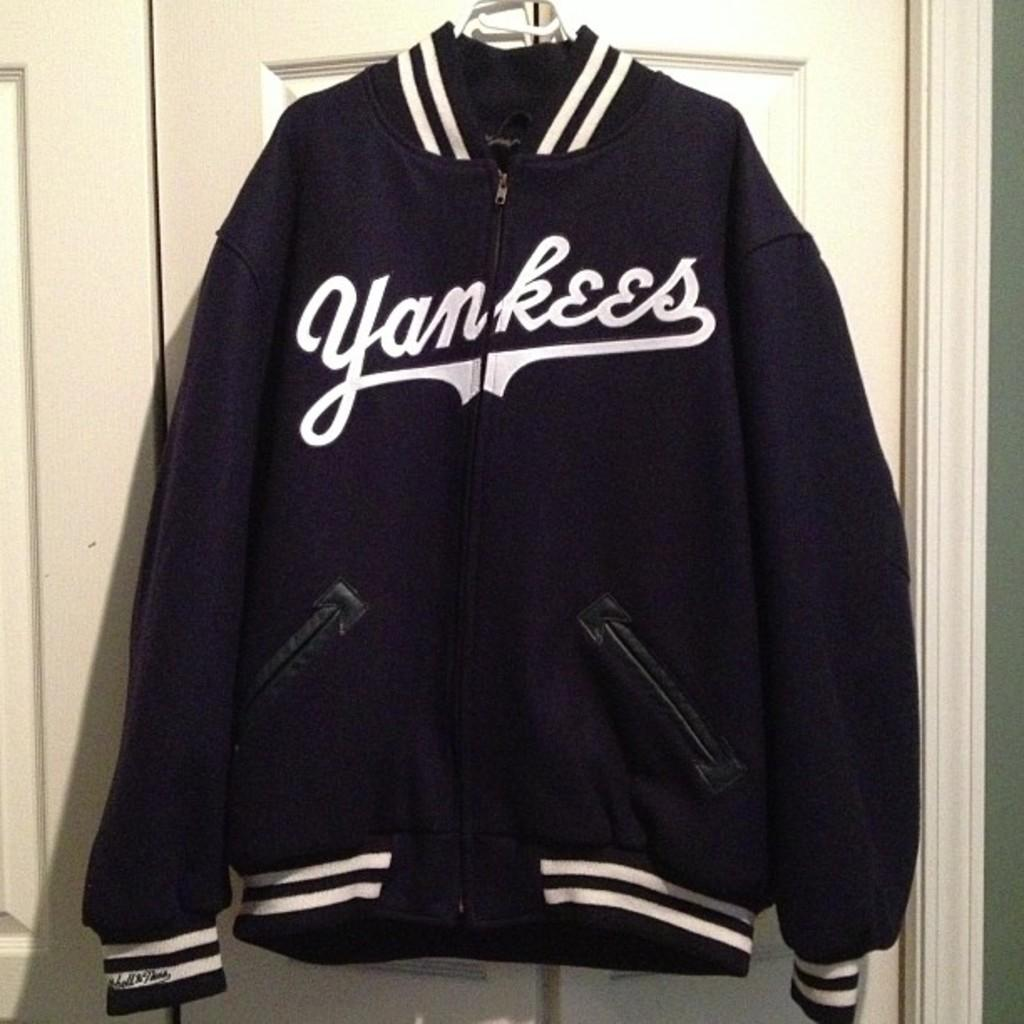<image>
Create a compact narrative representing the image presented. Dark Purple Yankees jacket hanging on a closet door. 